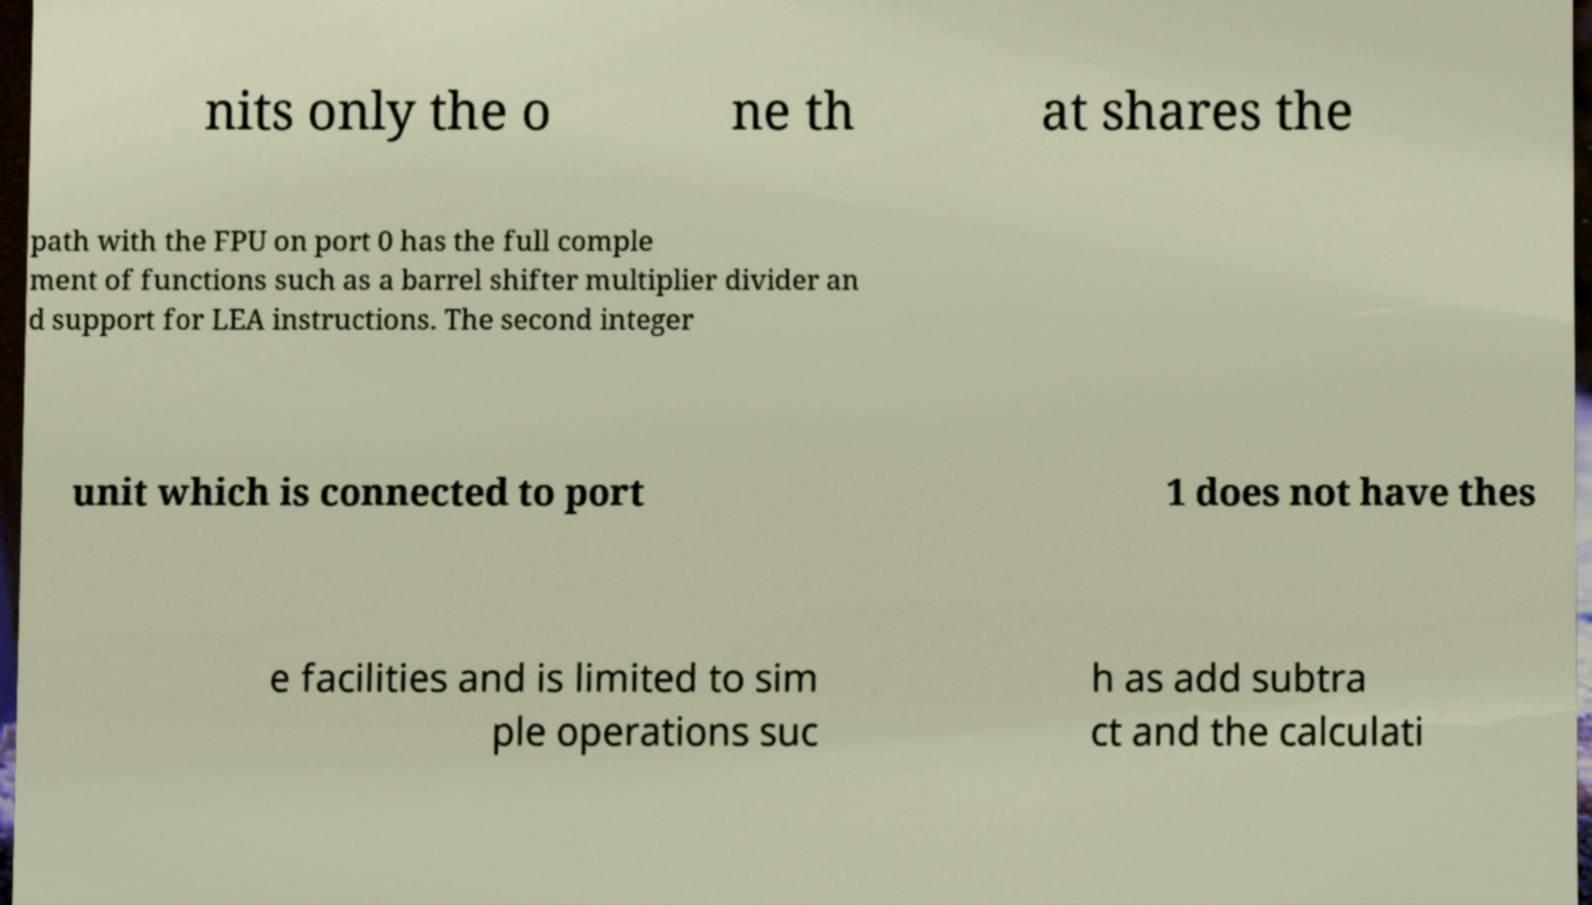Please identify and transcribe the text found in this image. nits only the o ne th at shares the path with the FPU on port 0 has the full comple ment of functions such as a barrel shifter multiplier divider an d support for LEA instructions. The second integer unit which is connected to port 1 does not have thes e facilities and is limited to sim ple operations suc h as add subtra ct and the calculati 